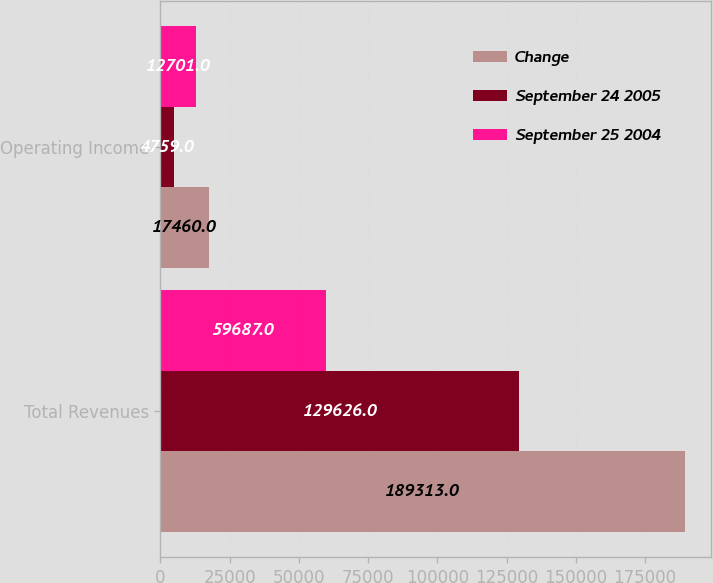<chart> <loc_0><loc_0><loc_500><loc_500><stacked_bar_chart><ecel><fcel>Total Revenues<fcel>Operating Income<nl><fcel>Change<fcel>189313<fcel>17460<nl><fcel>September 24 2005<fcel>129626<fcel>4759<nl><fcel>September 25 2004<fcel>59687<fcel>12701<nl></chart> 